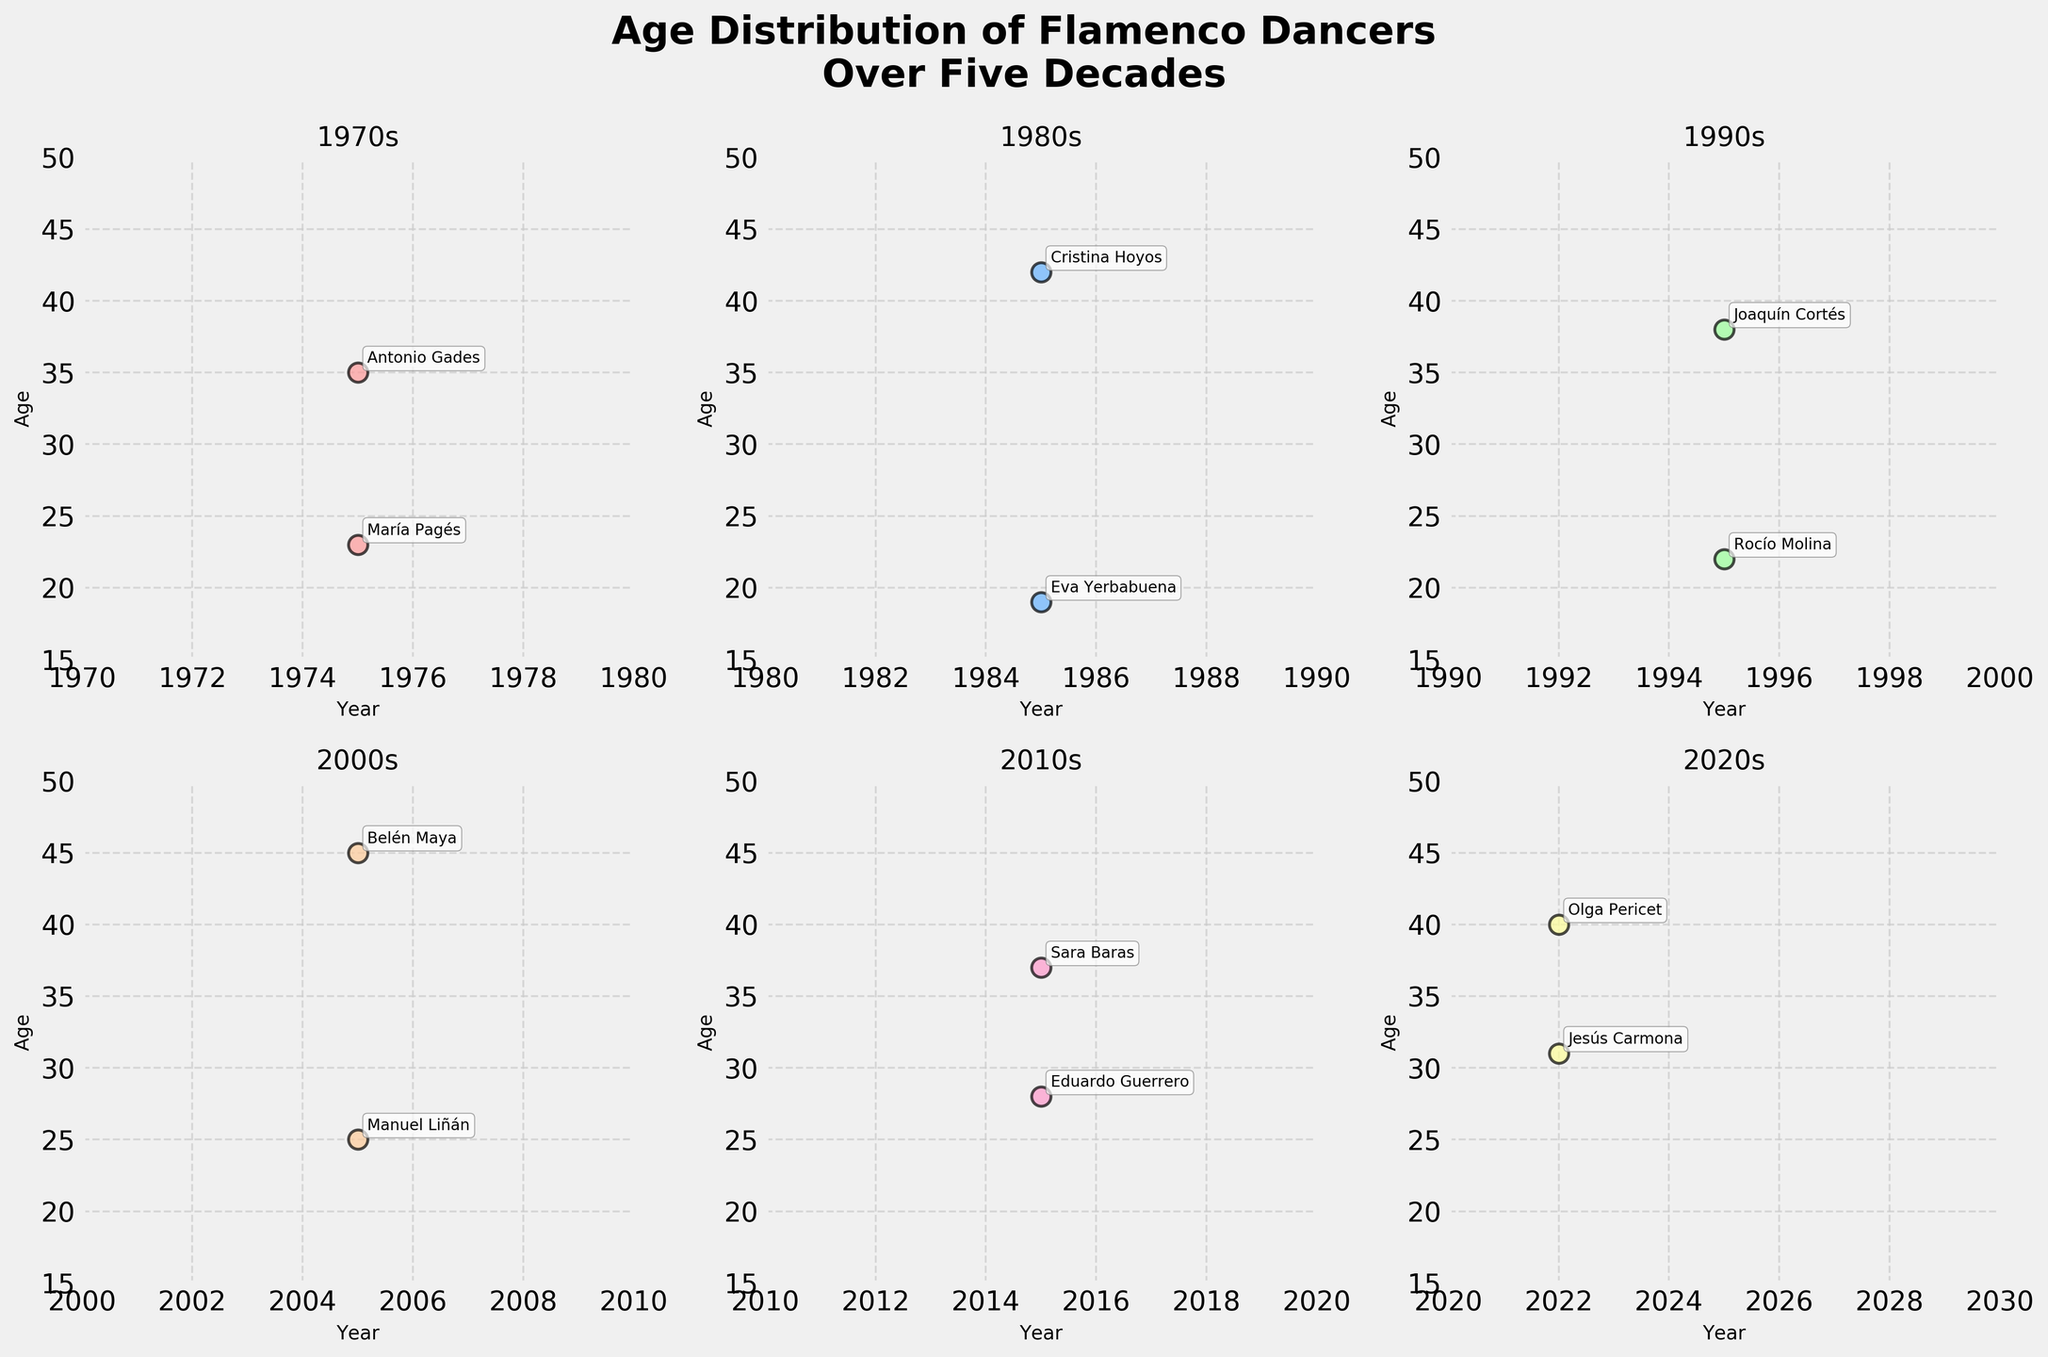What is the title of the figure? The title is usually located at the top center of the figure. In this case, it should be written in bold and larger font than the other text.
Answer: Age Distribution of Flamenco Dancers Over Five Decades In which decade was the youngest dancer performing, and how old were they? To find the youngest dancer, look at the y-axis values and locate the smallest age. Then note the corresponding decade from the x-axis or subplot title.
Answer: 1980s, 19 years old What is the range of ages represented in the 2000s decade? To determine the range, find the minimum and maximum age values in the 2000s subplot, and then subtract the minimum from the maximum.
Answer: 25 to 45 Which decade sees the highest age recorded for a flamenco dancer, and what is the age? Look at all subplots and identify the highest y-axis value. Note the dancer's age and the corresponding decade from the title.
Answer: 2000s, 45 years old Who are the two dancers from the 2020s decade, and what are their ages? Locate the subplot for the 2020s and find the data points. Annotate labels provide the dancer names and y-axis values show their ages.
Answer: Olga Pericet (40), Jesús Carmona (31) How does the age distribution trend change from the 1970s to the 2020s? Compare the ages across the decades. Consider the visual spread and center of age distributions in each subplot to detect trends.
Answer: Younger ages in earlier decades, more varied ages in later decades Does any decade have dancers whose ages are identical? If so, name them. Check each decade's subplot to see if any y-values (ages) are repeated. Use annotation labels to identify the dancers.
Answer: No identical ages in any decade What is the average age of dancers in the 1990s? Add the ages of all dancers in the 1990s subplot and divide by the number of dancers to compute the average.
Answer: (22 + 38) / 2 = 30 years 